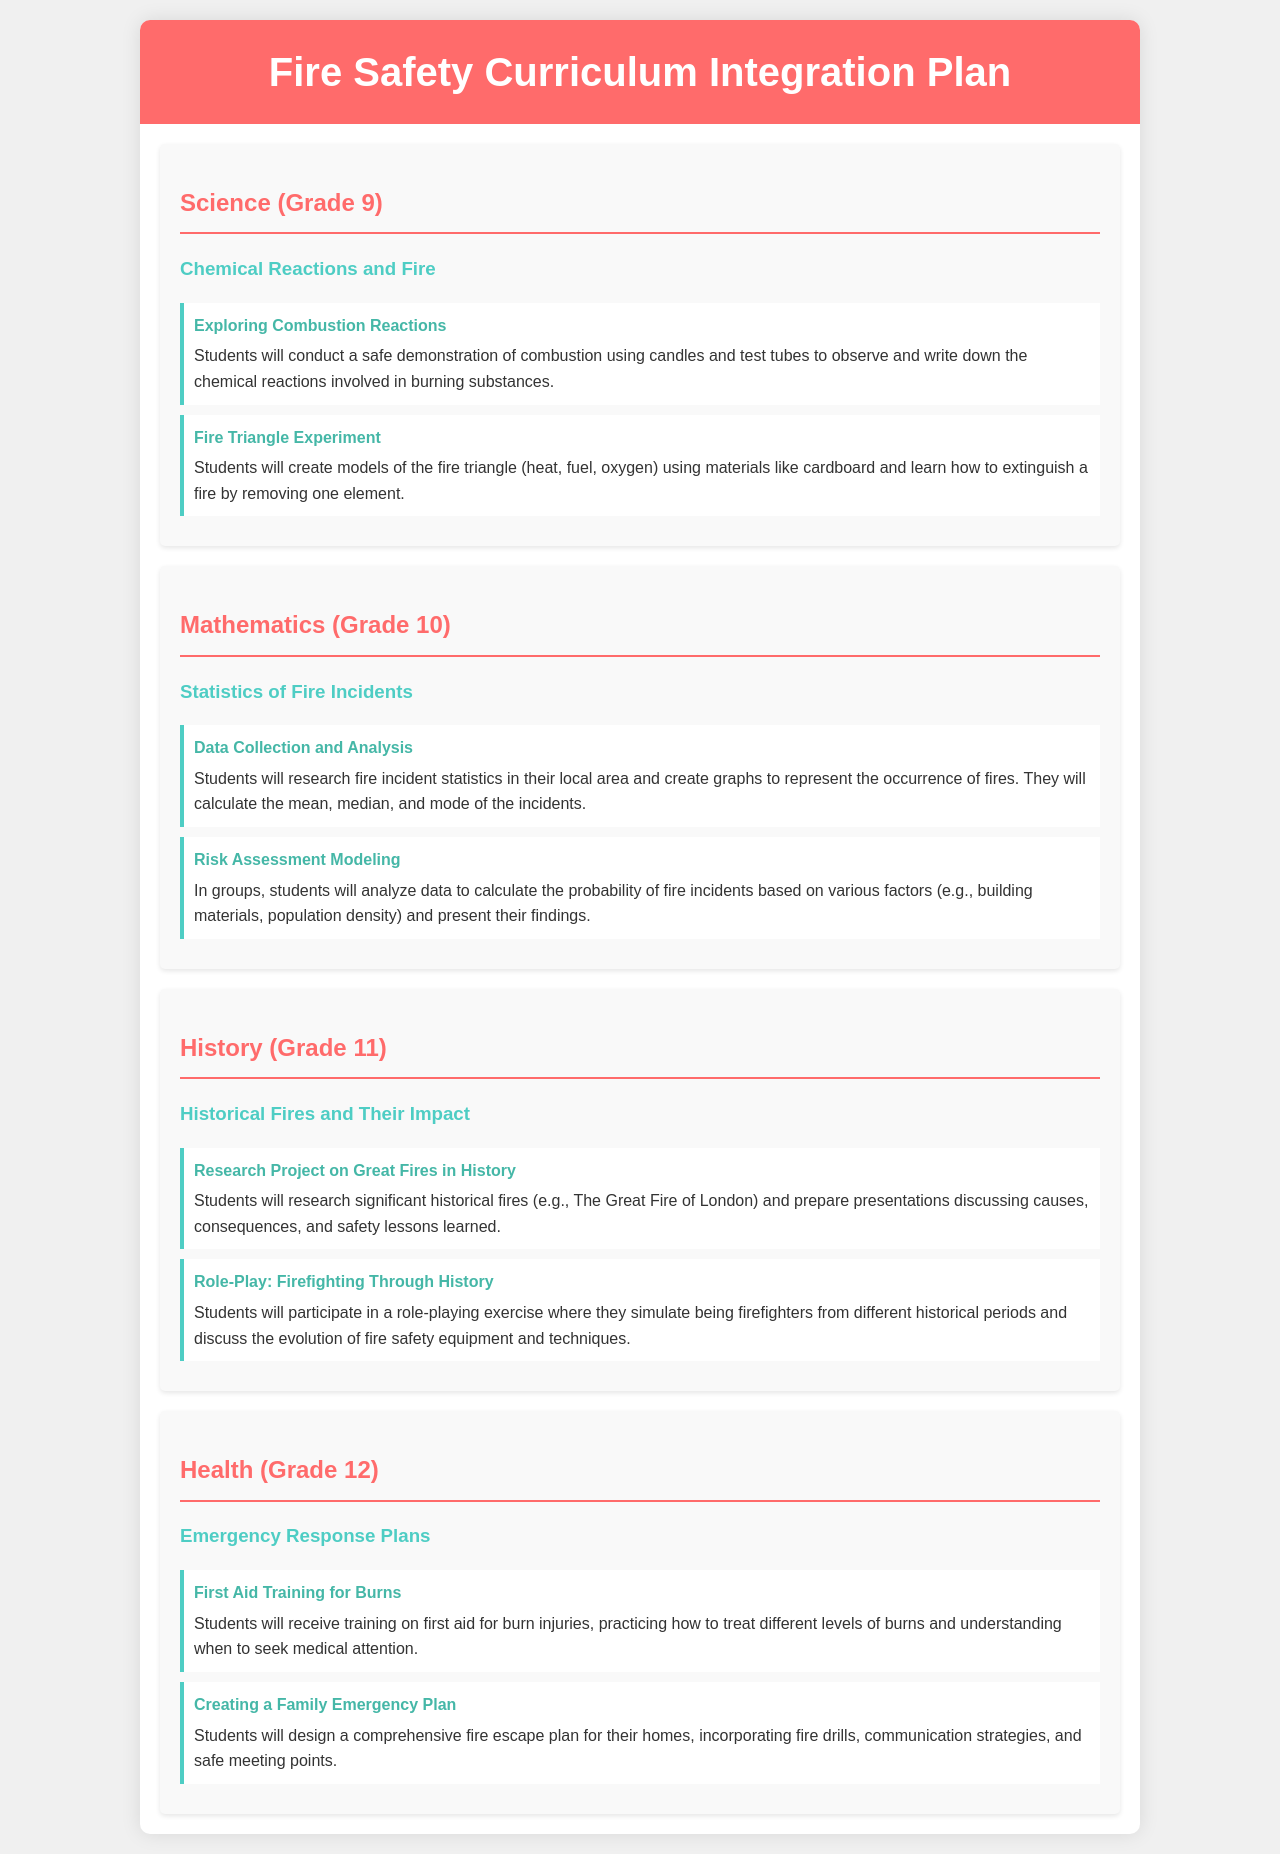What is the main title of the document? The main title is found in the header section, representing the overall theme of the document.
Answer: Fire Safety Curriculum Integration Plan Which grade is associated with the "Exploring Combustion Reactions" activity? The grade level for activities is indicated in the subject area.
Answer: Grade 9 What mathematical concept do students learn in the "Risk Assessment Modeling" activity? The concept students analyze involves understanding probabilities based on data, which is a mathematical concept.
Answer: Probability What historical event is researched in the "Research Project on Great Fires in History" activity? The specific historical event is mentioned in the description of the activity, highlighting an important fire in history.
Answer: The Great Fire of London What is the focus of the Health subject for Grade 12? The subject focus indicates a discussion around specific emergency response practices for students.
Answer: Emergency Response Plans In which subject do students study "Statistics of Fire Incidents"? The subject area titles specify the context and topics discussed in each part of the document.
Answer: Mathematics What type of training do students receive in the activity related to burns? The specific type of training given to students is detailed within the activity description, focusing on safety measures.
Answer: First Aid Training What do students create in the "Creating a Family Emergency Plan" activity? The results expected from this activity are outlined in the description, detailing a specific deliverable for students.
Answer: Fire escape plan 